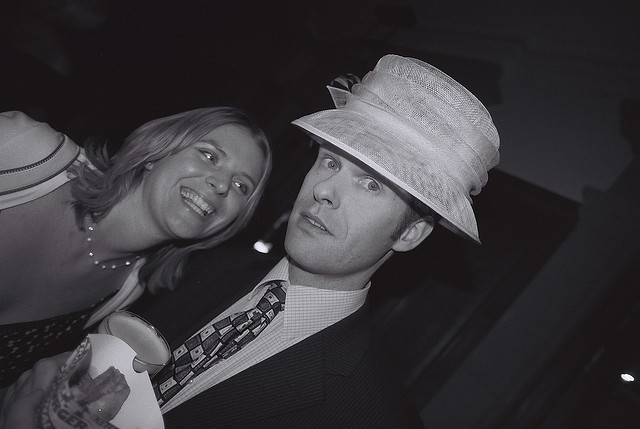Describe the man's attire. The man is wearing a classy suit with a tie, topped with a light-colored fedora hat which adds a distinctive touch to his outfit. What about the woman's attire? Though not fully visible, the woman appears to be wearing a white or light-colored top or dress with a wide neckline, suggesting a semi-formal or formal style. 